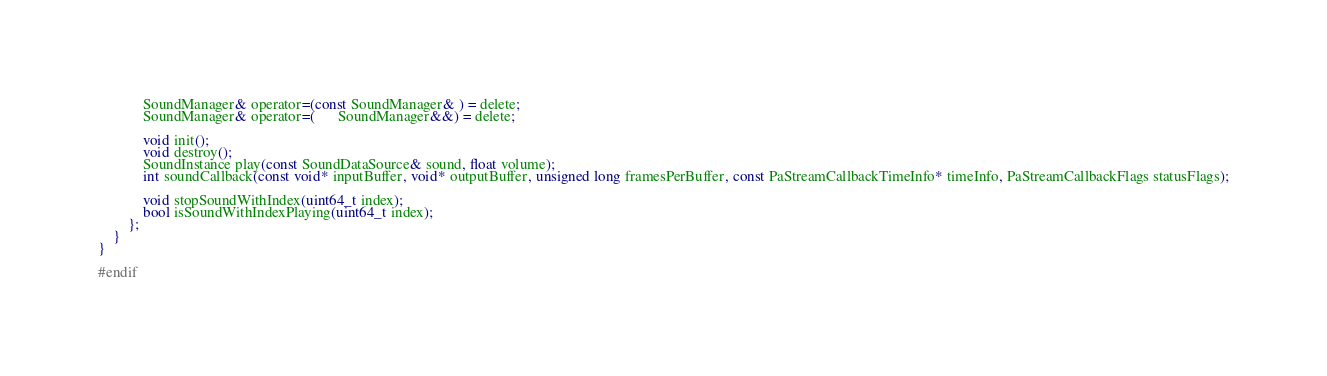<code> <loc_0><loc_0><loc_500><loc_500><_C_>			SoundManager& operator=(const SoundManager& ) = delete;
			SoundManager& operator=(      SoundManager&&) = delete;

			void init();
			void destroy();
			SoundInstance play(const SoundDataSource& sound, float volume);
			int soundCallback(const void* inputBuffer, void* outputBuffer, unsigned long framesPerBuffer, const PaStreamCallbackTimeInfo* timeInfo, PaStreamCallbackFlags statusFlags);

			void stopSoundWithIndex(uint64_t index);
			bool isSoundWithIndexPlaying(uint64_t index);
		};
	}
}

#endif
</code> 